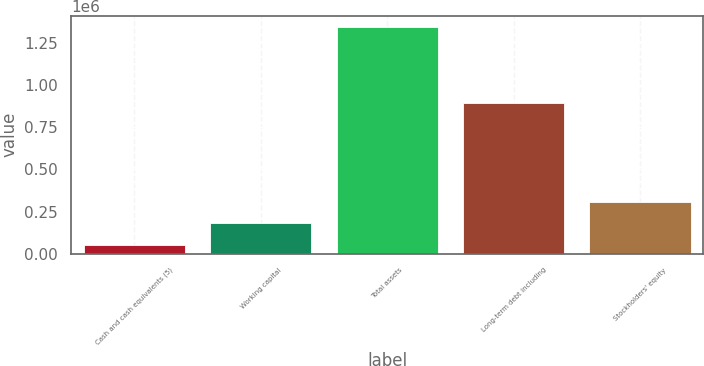Convert chart to OTSL. <chart><loc_0><loc_0><loc_500><loc_500><bar_chart><fcel>Cash and cash equivalents (5)<fcel>Working capital<fcel>Total assets<fcel>Long-term debt including<fcel>Stockholders' equity<nl><fcel>48498<fcel>179385<fcel>1.34591e+06<fcel>892788<fcel>309126<nl></chart> 